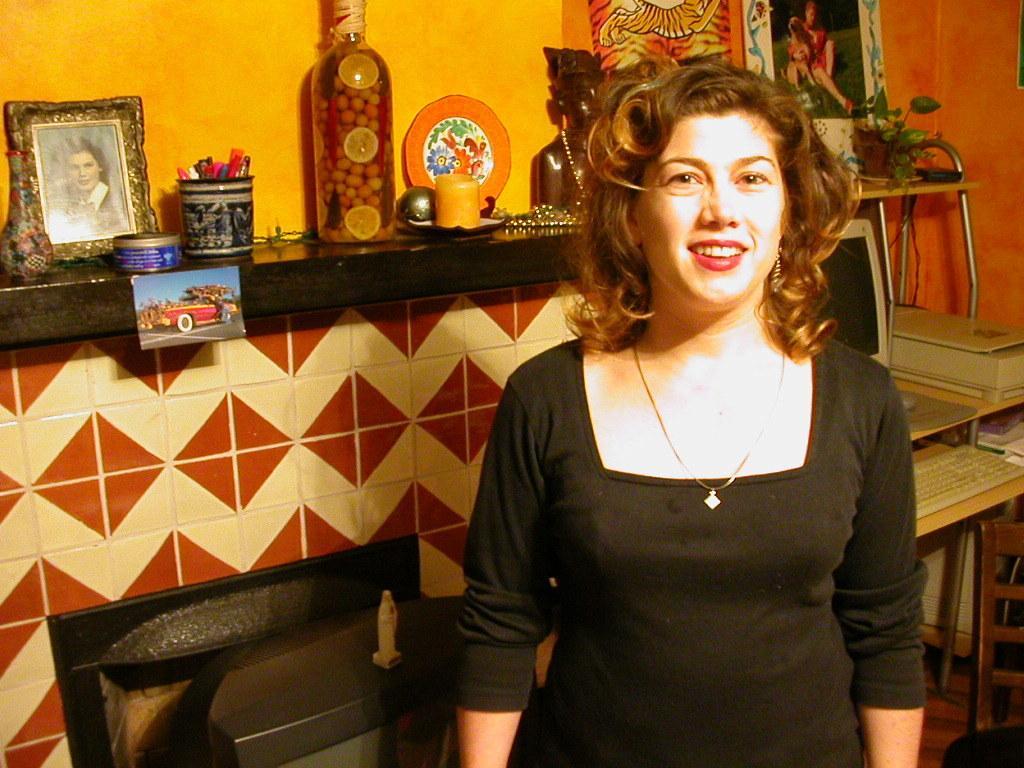Describe this image in one or two sentences. in this picture we can see a woman is standing and she is smiling, and at back there is wall, and there are some objects like photo frame, bottle pens and her is the flower pot and her is the computer and keyboard. 